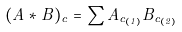Convert formula to latex. <formula><loc_0><loc_0><loc_500><loc_500>( A * B ) _ { c } = \sum A _ { c _ { ( 1 ) } } B _ { c _ { ( 2 ) } }</formula> 